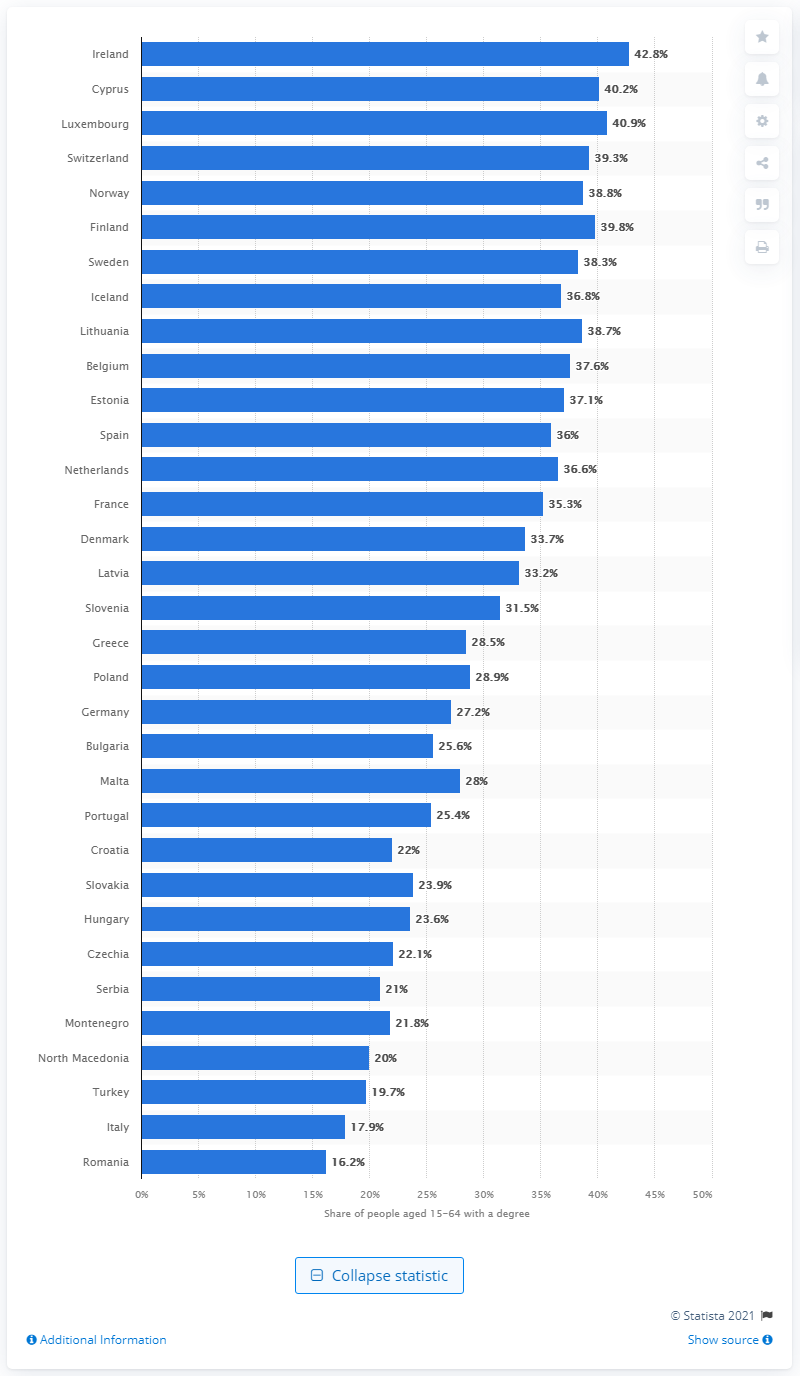Point out several critical features in this image. In 2020, Ireland had the highest percentage of graduates among all countries. 